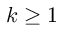Convert formula to latex. <formula><loc_0><loc_0><loc_500><loc_500>k \geq 1</formula> 